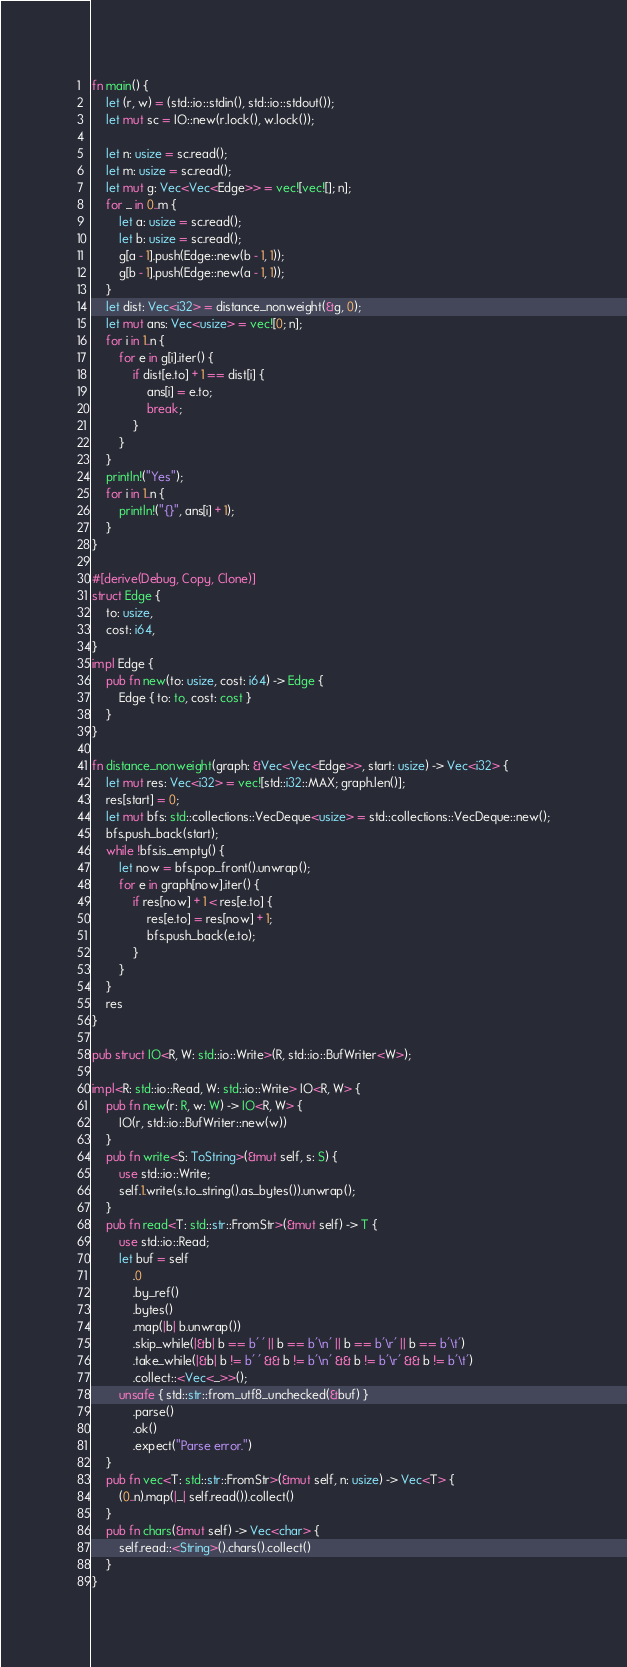<code> <loc_0><loc_0><loc_500><loc_500><_Rust_>fn main() {
    let (r, w) = (std::io::stdin(), std::io::stdout());
    let mut sc = IO::new(r.lock(), w.lock());

    let n: usize = sc.read();
    let m: usize = sc.read();
    let mut g: Vec<Vec<Edge>> = vec![vec![]; n];
    for _ in 0..m {
        let a: usize = sc.read();
        let b: usize = sc.read();
        g[a - 1].push(Edge::new(b - 1, 1));
        g[b - 1].push(Edge::new(a - 1, 1));
    }
    let dist: Vec<i32> = distance_nonweight(&g, 0);
    let mut ans: Vec<usize> = vec![0; n];
    for i in 1..n {
        for e in g[i].iter() {
            if dist[e.to] + 1 == dist[i] {
                ans[i] = e.to;
                break;
            }
        }
    }
    println!("Yes");
    for i in 1..n {
        println!("{}", ans[i] + 1);
    }
}

#[derive(Debug, Copy, Clone)]
struct Edge {
    to: usize,
    cost: i64,
}
impl Edge {
    pub fn new(to: usize, cost: i64) -> Edge {
        Edge { to: to, cost: cost }
    }
}

fn distance_nonweight(graph: &Vec<Vec<Edge>>, start: usize) -> Vec<i32> {
    let mut res: Vec<i32> = vec![std::i32::MAX; graph.len()];
    res[start] = 0;
    let mut bfs: std::collections::VecDeque<usize> = std::collections::VecDeque::new();
    bfs.push_back(start);
    while !bfs.is_empty() {
        let now = bfs.pop_front().unwrap();
        for e in graph[now].iter() {
            if res[now] + 1 < res[e.to] {
                res[e.to] = res[now] + 1;
                bfs.push_back(e.to);
            }
        }
    }
    res
}

pub struct IO<R, W: std::io::Write>(R, std::io::BufWriter<W>);

impl<R: std::io::Read, W: std::io::Write> IO<R, W> {
    pub fn new(r: R, w: W) -> IO<R, W> {
        IO(r, std::io::BufWriter::new(w))
    }
    pub fn write<S: ToString>(&mut self, s: S) {
        use std::io::Write;
        self.1.write(s.to_string().as_bytes()).unwrap();
    }
    pub fn read<T: std::str::FromStr>(&mut self) -> T {
        use std::io::Read;
        let buf = self
            .0
            .by_ref()
            .bytes()
            .map(|b| b.unwrap())
            .skip_while(|&b| b == b' ' || b == b'\n' || b == b'\r' || b == b'\t')
            .take_while(|&b| b != b' ' && b != b'\n' && b != b'\r' && b != b'\t')
            .collect::<Vec<_>>();
        unsafe { std::str::from_utf8_unchecked(&buf) }
            .parse()
            .ok()
            .expect("Parse error.")
    }
    pub fn vec<T: std::str::FromStr>(&mut self, n: usize) -> Vec<T> {
        (0..n).map(|_| self.read()).collect()
    }
    pub fn chars(&mut self) -> Vec<char> {
        self.read::<String>().chars().collect()
    }
}</code> 